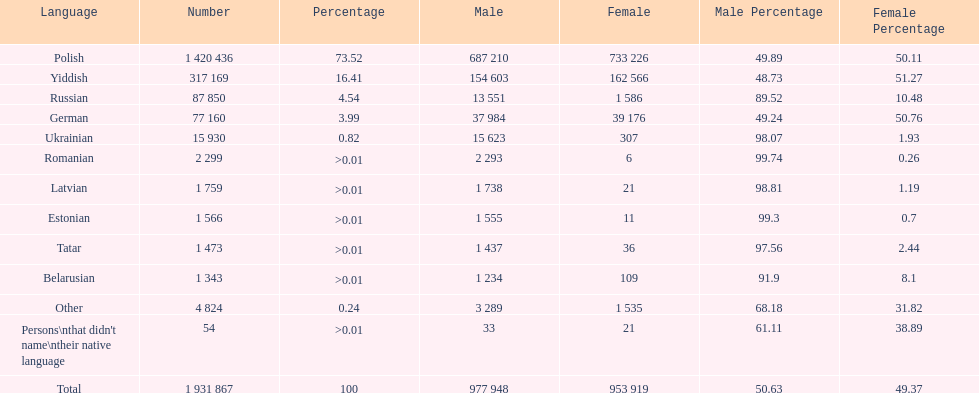Which language had the smallest number of females speaking it. Romanian. 